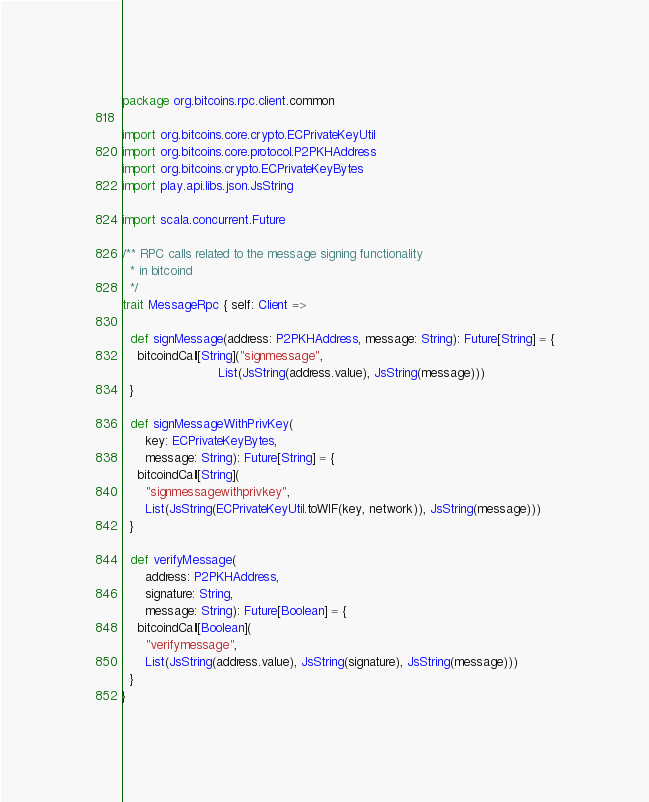<code> <loc_0><loc_0><loc_500><loc_500><_Scala_>package org.bitcoins.rpc.client.common

import org.bitcoins.core.crypto.ECPrivateKeyUtil
import org.bitcoins.core.protocol.P2PKHAddress
import org.bitcoins.crypto.ECPrivateKeyBytes
import play.api.libs.json.JsString

import scala.concurrent.Future

/** RPC calls related to the message signing functionality
  * in bitcoind
  */
trait MessageRpc { self: Client =>

  def signMessage(address: P2PKHAddress, message: String): Future[String] = {
    bitcoindCall[String]("signmessage",
                         List(JsString(address.value), JsString(message)))
  }

  def signMessageWithPrivKey(
      key: ECPrivateKeyBytes,
      message: String): Future[String] = {
    bitcoindCall[String](
      "signmessagewithprivkey",
      List(JsString(ECPrivateKeyUtil.toWIF(key, network)), JsString(message)))
  }

  def verifyMessage(
      address: P2PKHAddress,
      signature: String,
      message: String): Future[Boolean] = {
    bitcoindCall[Boolean](
      "verifymessage",
      List(JsString(address.value), JsString(signature), JsString(message)))
  }
}
</code> 